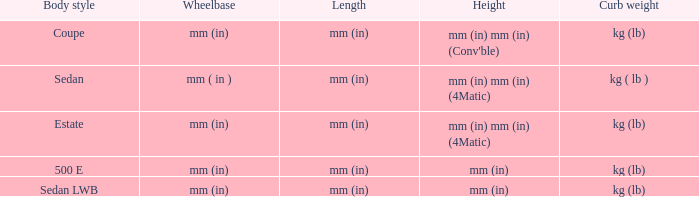What are the lengths of the models that are mm (in) tall? Mm (in), mm (in). 